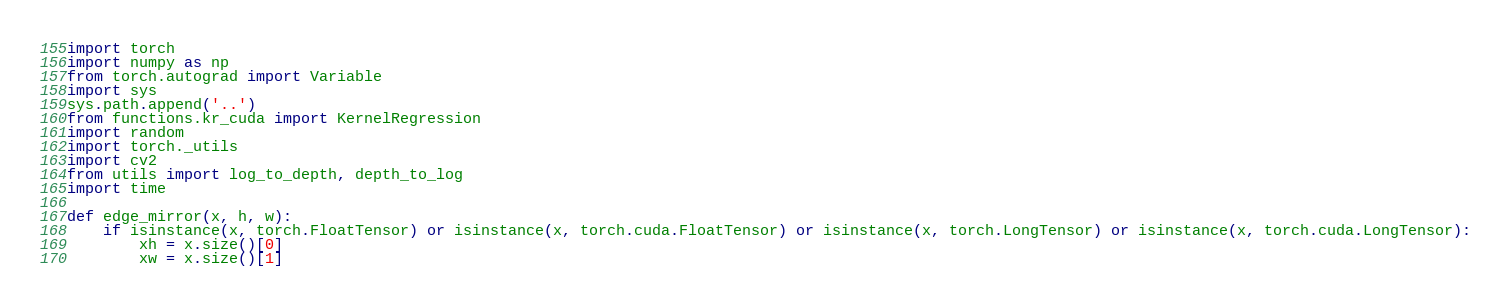Convert code to text. <code><loc_0><loc_0><loc_500><loc_500><_Python_>import torch
import numpy as np
from torch.autograd import Variable
import sys
sys.path.append('..')
from functions.kr_cuda import KernelRegression
import random
import torch._utils
import cv2
from utils import log_to_depth, depth_to_log
import time

def edge_mirror(x, h, w):
    if isinstance(x, torch.FloatTensor) or isinstance(x, torch.cuda.FloatTensor) or isinstance(x, torch.LongTensor) or isinstance(x, torch.cuda.LongTensor):
        xh = x.size()[0]
        xw = x.size()[1]</code> 